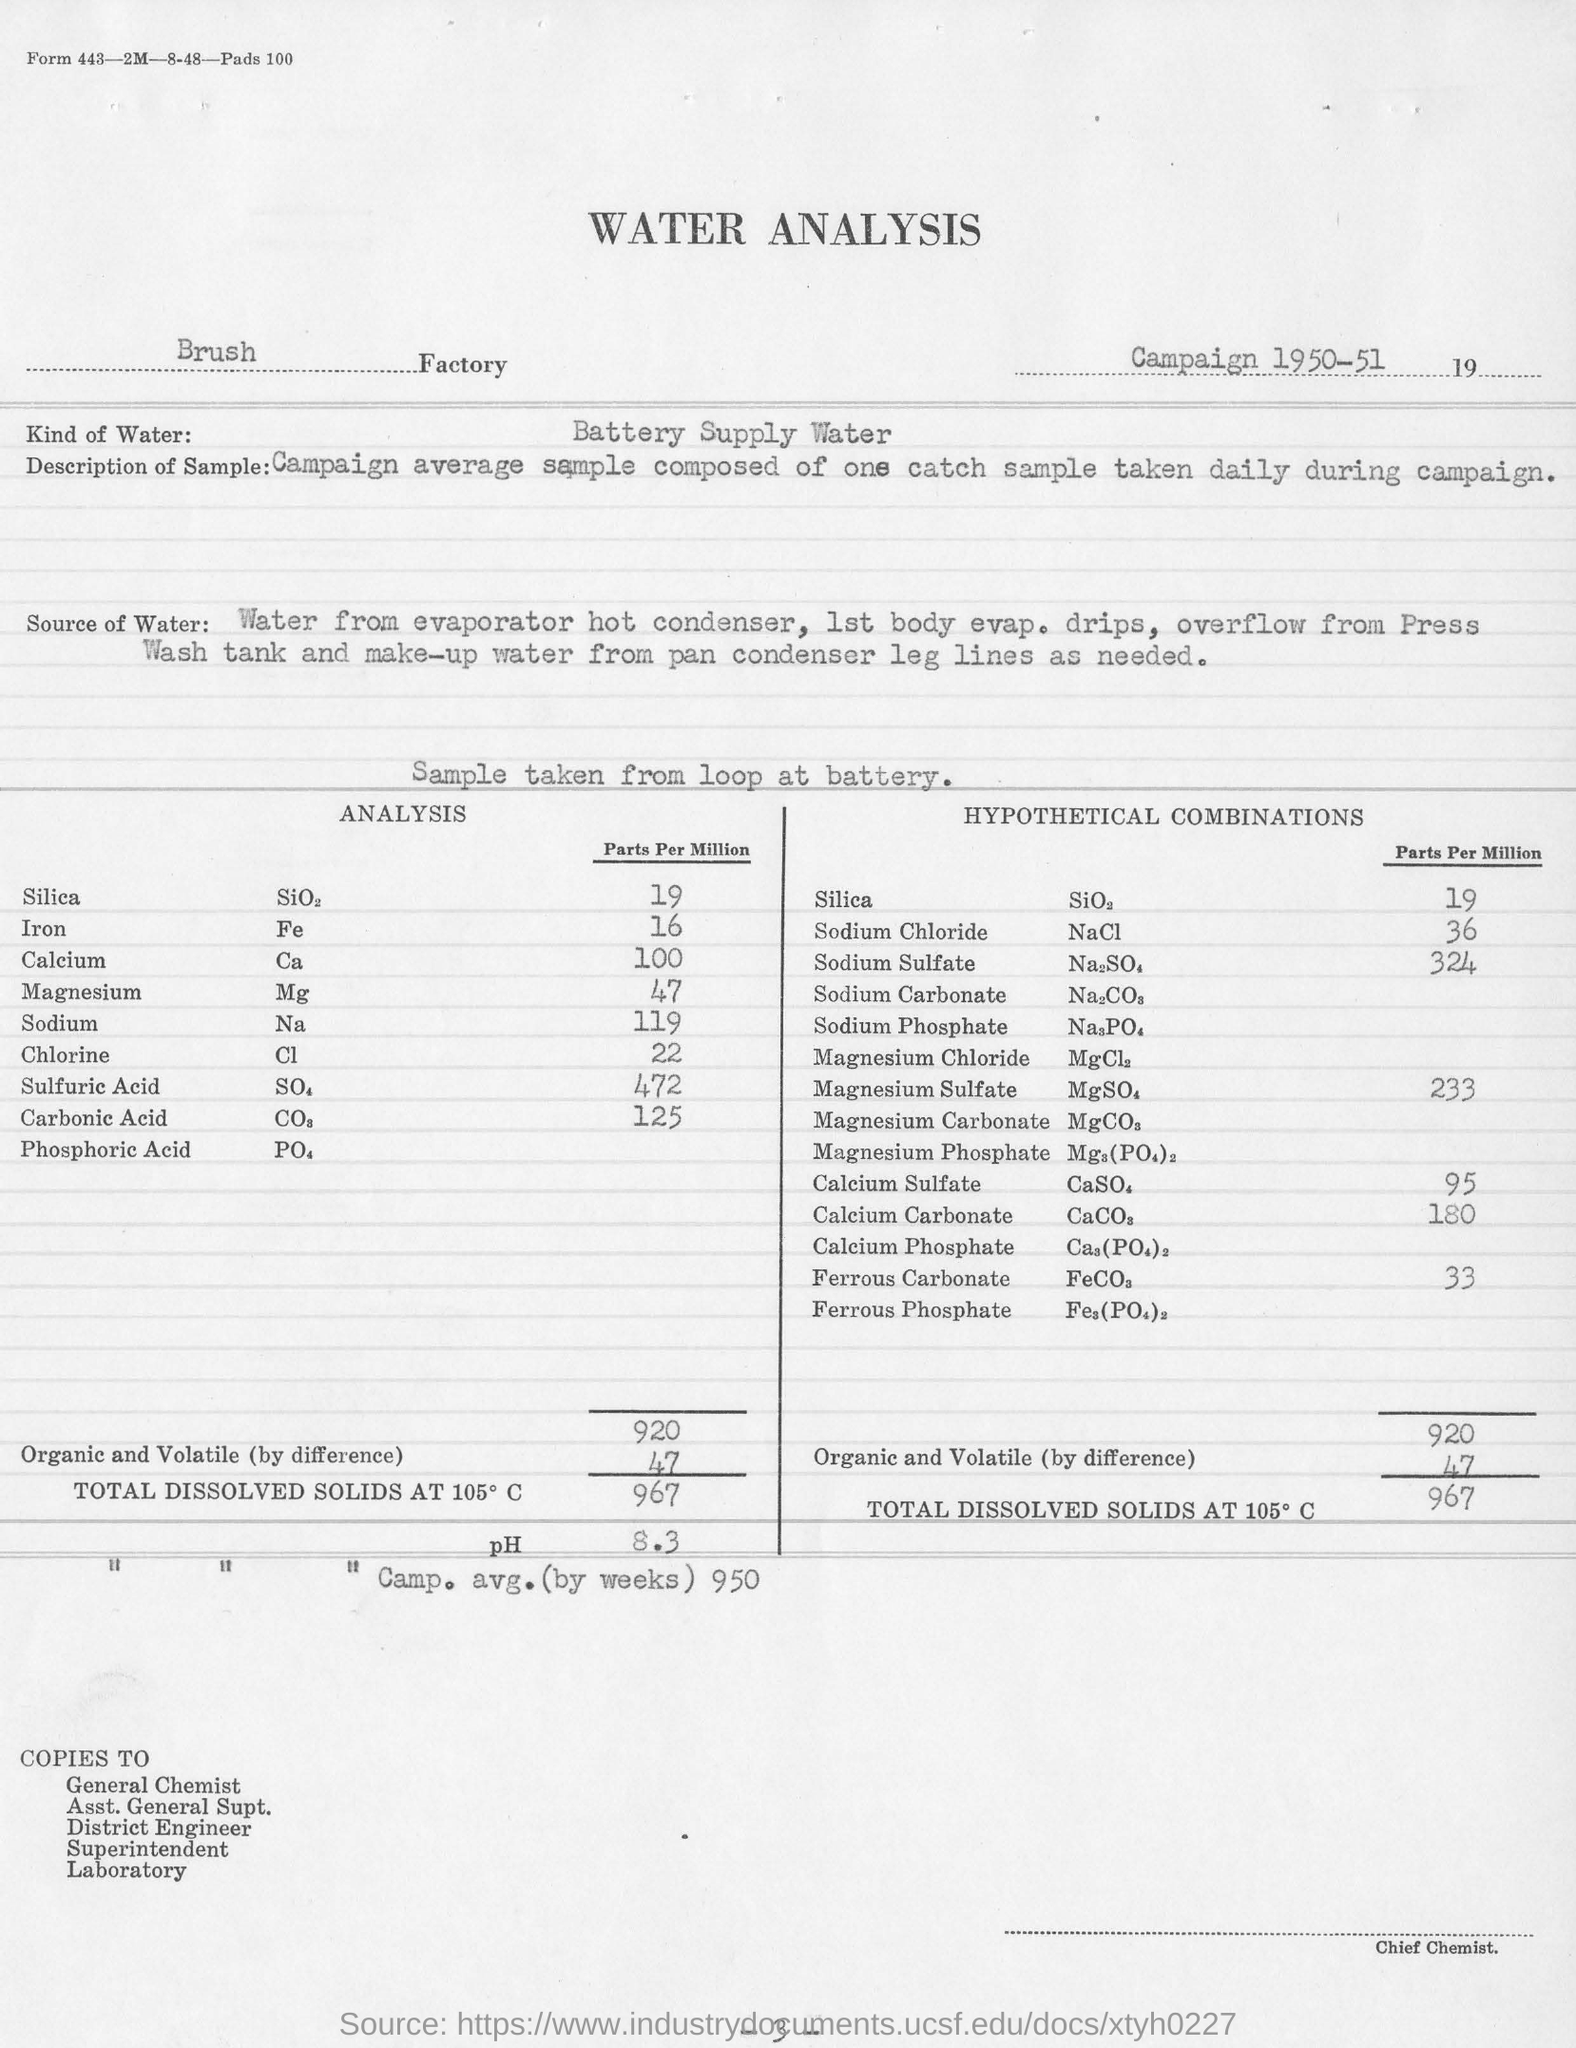Which Factory has done the Water Analysis?
Make the answer very short. Brush Factory. What kind of water is used for analysis?
Offer a very short reply. Battery supply water. Where is the water sample taken from?
Offer a very short reply. From loop at battery. How much is the Calcium Sulphate in HYPOTHETICAL COMBINATIONS?
Your answer should be very brief. 95 Parts Per Million. 